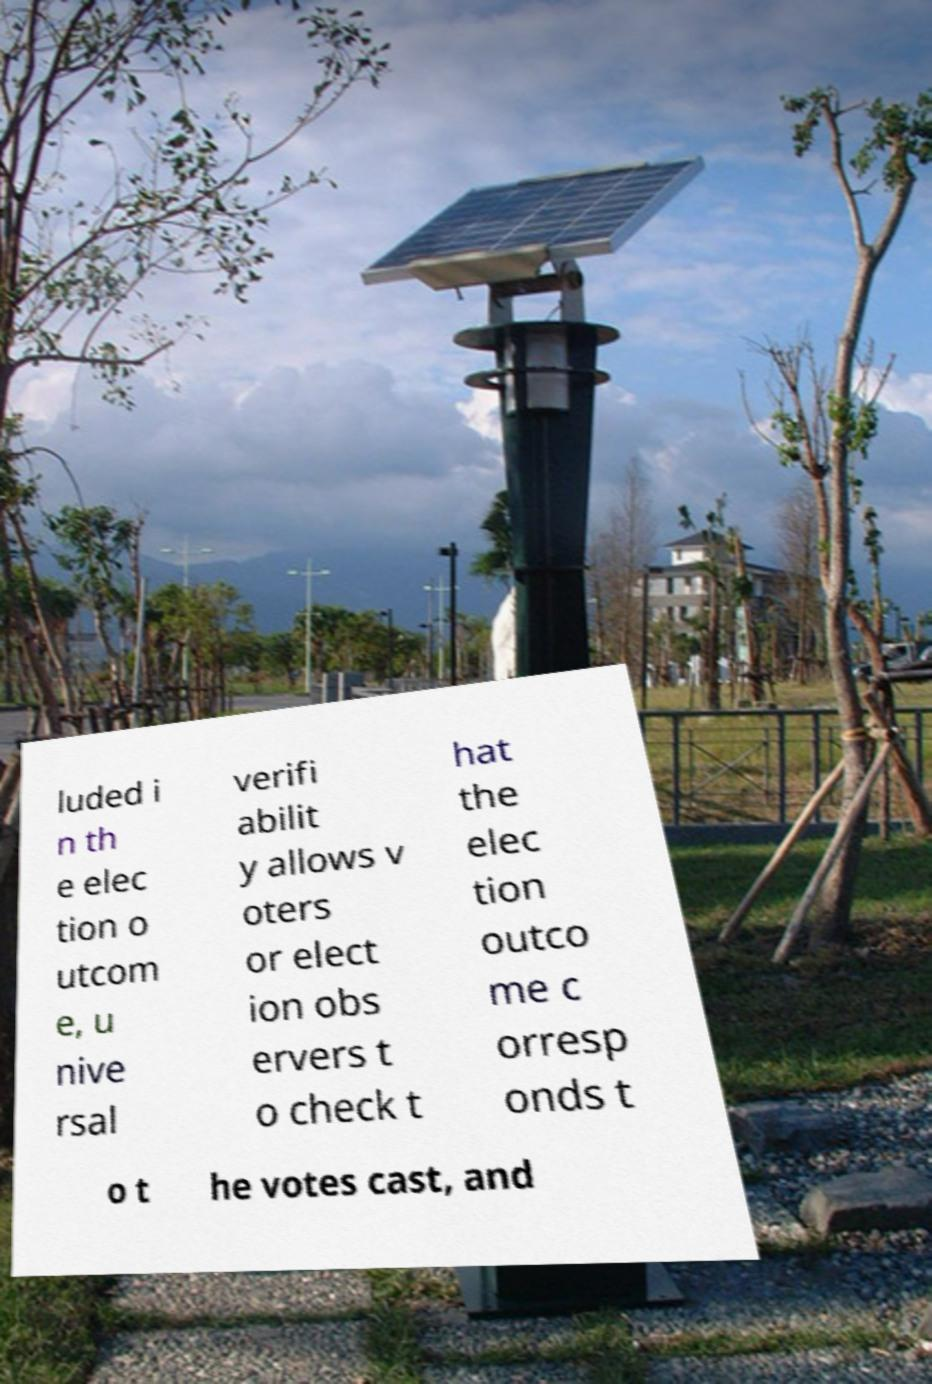I need the written content from this picture converted into text. Can you do that? luded i n th e elec tion o utcom e, u nive rsal verifi abilit y allows v oters or elect ion obs ervers t o check t hat the elec tion outco me c orresp onds t o t he votes cast, and 